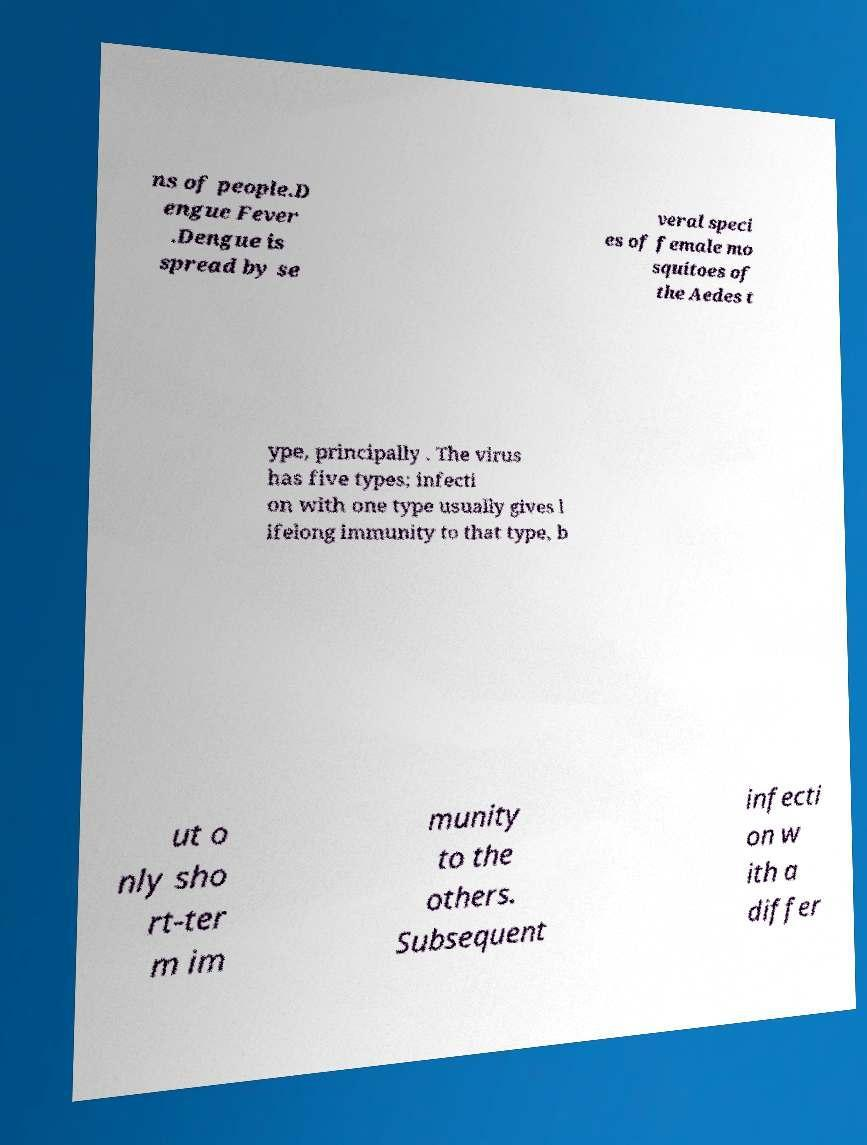Can you accurately transcribe the text from the provided image for me? ns of people.D engue Fever .Dengue is spread by se veral speci es of female mo squitoes of the Aedes t ype, principally . The virus has five types; infecti on with one type usually gives l ifelong immunity to that type, b ut o nly sho rt-ter m im munity to the others. Subsequent infecti on w ith a differ 